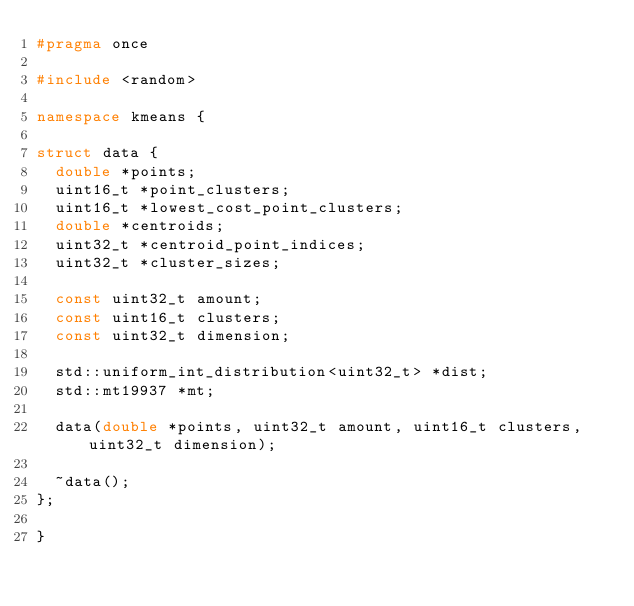<code> <loc_0><loc_0><loc_500><loc_500><_C++_>#pragma once

#include <random>

namespace kmeans {

struct data {
  double *points;
  uint16_t *point_clusters;
  uint16_t *lowest_cost_point_clusters;
  double *centroids;
  uint32_t *centroid_point_indices;
  uint32_t *cluster_sizes;

  const uint32_t amount;
  const uint16_t clusters;
  const uint32_t dimension;

  std::uniform_int_distribution<uint32_t> *dist;
  std::mt19937 *mt;

  data(double *points, uint32_t amount, uint16_t clusters, uint32_t dimension);

  ~data();
};

}
</code> 